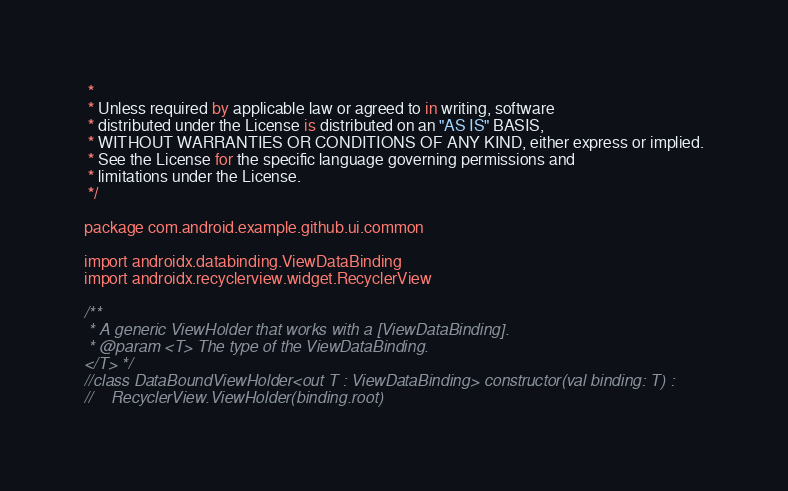<code> <loc_0><loc_0><loc_500><loc_500><_Kotlin_> *
 * Unless required by applicable law or agreed to in writing, software
 * distributed under the License is distributed on an "AS IS" BASIS,
 * WITHOUT WARRANTIES OR CONDITIONS OF ANY KIND, either express or implied.
 * See the License for the specific language governing permissions and
 * limitations under the License.
 */

package com.android.example.github.ui.common

import androidx.databinding.ViewDataBinding
import androidx.recyclerview.widget.RecyclerView

/**
 * A generic ViewHolder that works with a [ViewDataBinding].
 * @param <T> The type of the ViewDataBinding.
</T> */
//class DataBoundViewHolder<out T : ViewDataBinding> constructor(val binding: T) :
//    RecyclerView.ViewHolder(binding.root)
</code> 